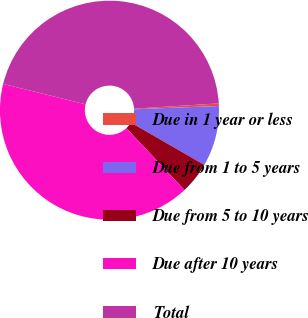Convert chart to OTSL. <chart><loc_0><loc_0><loc_500><loc_500><pie_chart><fcel>Due in 1 year or less<fcel>Due from 1 to 5 years<fcel>Due from 5 to 10 years<fcel>Due after 10 years<fcel>Total<nl><fcel>0.38%<fcel>8.94%<fcel>4.66%<fcel>40.87%<fcel>45.15%<nl></chart> 